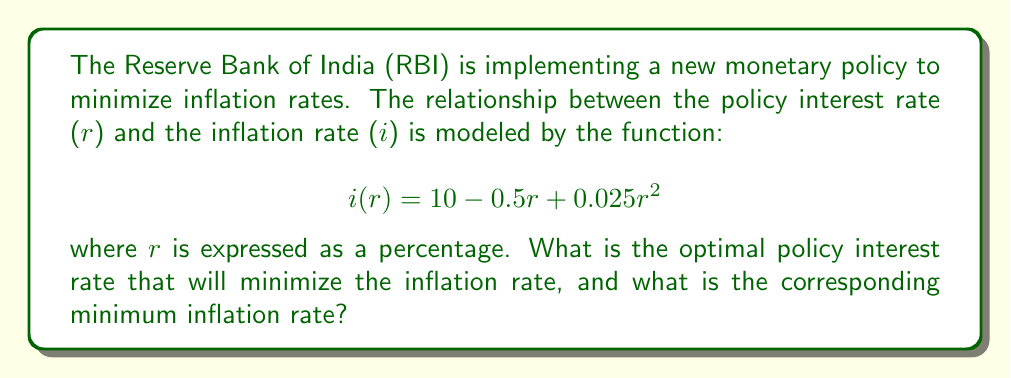Can you answer this question? To solve this optimization problem, we need to follow these steps:

1) The function $i(r)$ represents the inflation rate in terms of the policy interest rate. To find the minimum inflation rate, we need to find the value of $r$ where the derivative of $i(r)$ equals zero.

2) Let's find the derivative of $i(r)$:

   $$i'(r) = -0.5 + 0.05r$$

3) Set the derivative equal to zero and solve for $r$:

   $$-0.5 + 0.05r = 0$$
   $$0.05r = 0.5$$
   $$r = 10$$

4) To confirm this is a minimum (not a maximum), we can check the second derivative:

   $$i''(r) = 0.05$$

   Since this is positive, we confirm that $r = 10$ gives a minimum.

5) Now that we have the optimal interest rate, we can calculate the minimum inflation rate by plugging $r = 10$ back into the original function:

   $$i(10) = 10 - 0.5(10) + 0.025(10)^2$$
   $$= 10 - 5 + 2.5$$
   $$= 7.5$$

Therefore, the optimal policy interest rate is 10%, which results in a minimum inflation rate of 7.5%.
Answer: The optimal policy interest rate is 10%, resulting in a minimum inflation rate of 7.5%. 